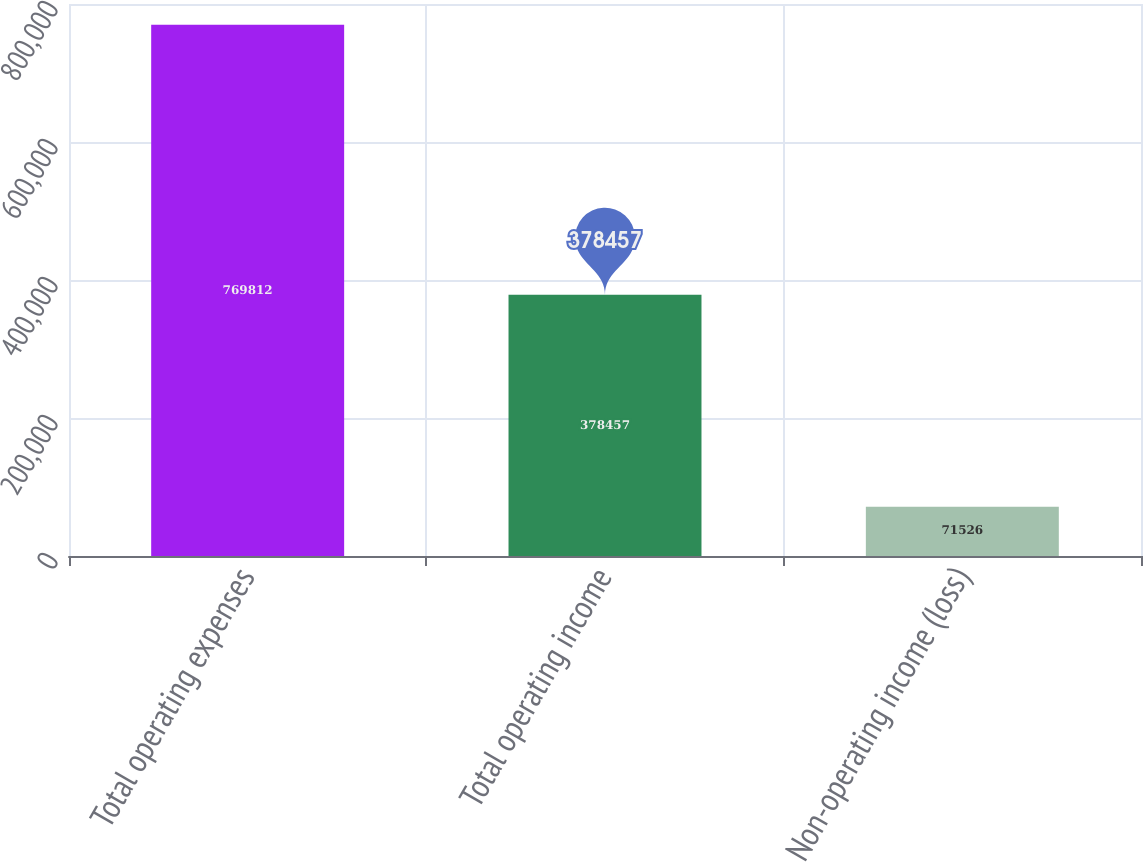Convert chart to OTSL. <chart><loc_0><loc_0><loc_500><loc_500><bar_chart><fcel>Total operating expenses<fcel>Total operating income<fcel>Non-operating income (loss)<nl><fcel>769812<fcel>378457<fcel>71526<nl></chart> 